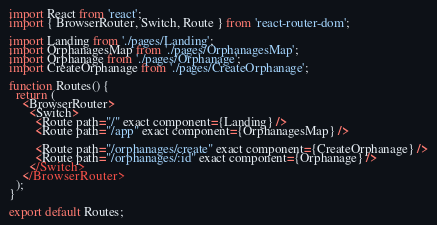Convert code to text. <code><loc_0><loc_0><loc_500><loc_500><_TypeScript_>import React from 'react';
import { BrowserRouter, Switch, Route } from 'react-router-dom';

import Landing from './pages/Landing';
import OrphanagesMap from './pages/OrphanagesMap';
import Orphanage from './pages/Orphanage';
import CreateOrphanage from './pages/CreateOrphanage';

function Routes() {
  return (
    <BrowserRouter>
      <Switch>
        <Route path="/" exact component={Landing} />
        <Route path="/app" exact component={OrphanagesMap} />

        <Route path="/orphanages/create" exact component={CreateOrphanage} />
        <Route path="/orphanages/:id" exact component={Orphanage} />
      </Switch>
    </BrowserRouter>
  );
}

export default Routes;</code> 